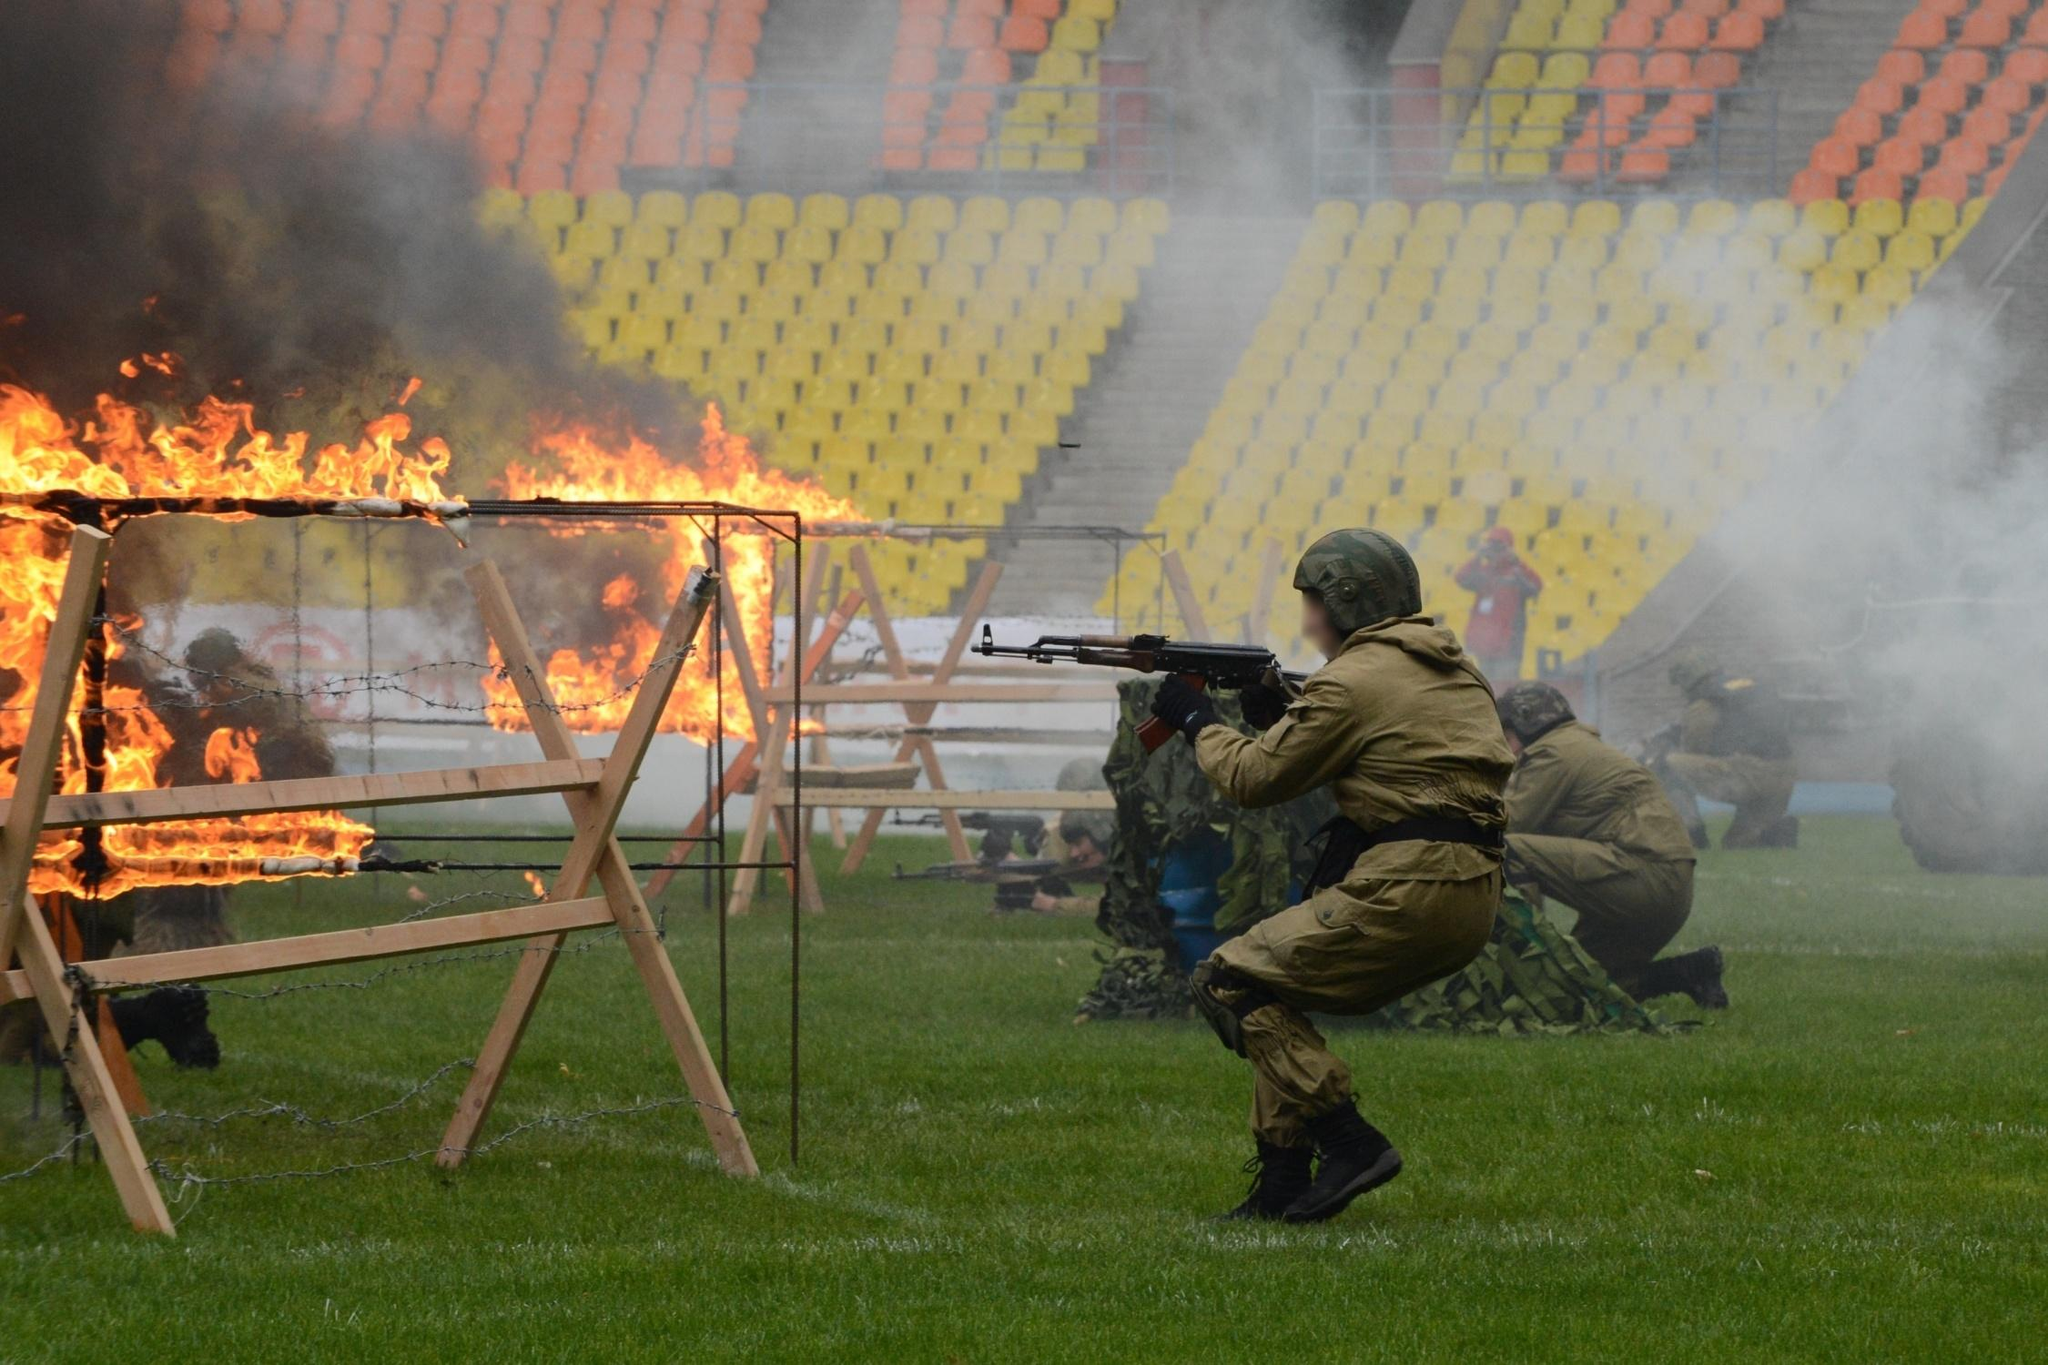What can you tell me about the equipment that the soldiers are using? The soldiers are equipped with standard military gear, which includes green camouflage uniforms, combat boots, and helmets providing necessary protection and concealment. Each soldier is armed with a rifle, likely used for marksmanship training within the scenario. This equipment is essential for both protection and efficacy in combat-like situations, intended to mimic real-world operations as closely as possible. How do the soldiers' postures contribute to their effectiveness in such drills? The crouching and ready positions of the soldiers are crucial for several reasons: they minimize the target size, allow for greater stability when shooting, and provide better cover from potential counterattacks. These postures are strategic, intended to enhance their agility, responsiveness, and ultimately their safety during real combat engagements. 